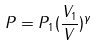<formula> <loc_0><loc_0><loc_500><loc_500>P = P _ { 1 } ( \frac { V _ { 1 } } { V } ) ^ { \gamma }</formula> 